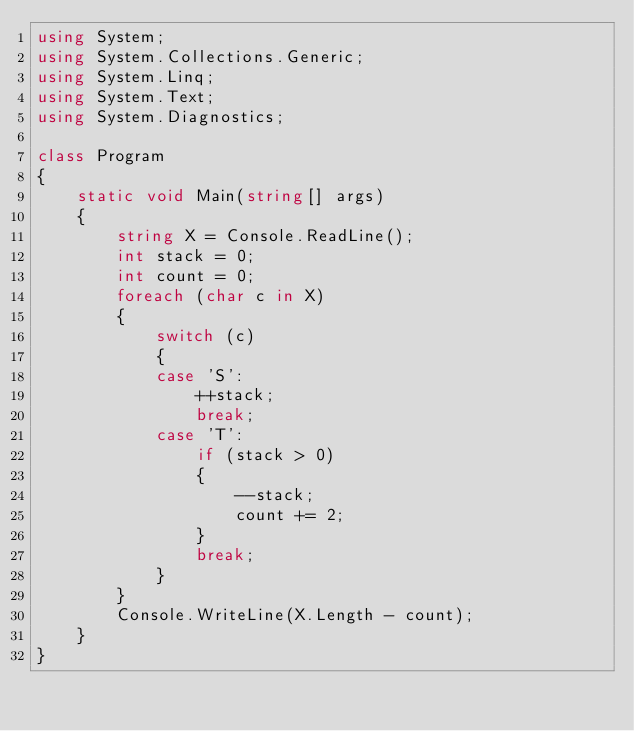Convert code to text. <code><loc_0><loc_0><loc_500><loc_500><_C#_>using System;
using System.Collections.Generic;
using System.Linq;
using System.Text;
using System.Diagnostics;

class Program
{
    static void Main(string[] args)
    {
        string X = Console.ReadLine();
        int stack = 0;
        int count = 0;
        foreach (char c in X)
        {
            switch (c)
            {
            case 'S':
                ++stack;
                break;
            case 'T':
                if (stack > 0)
                {
                    --stack;
                    count += 2;
                }
                break;
            }
        }
        Console.WriteLine(X.Length - count);
    }
}
</code> 